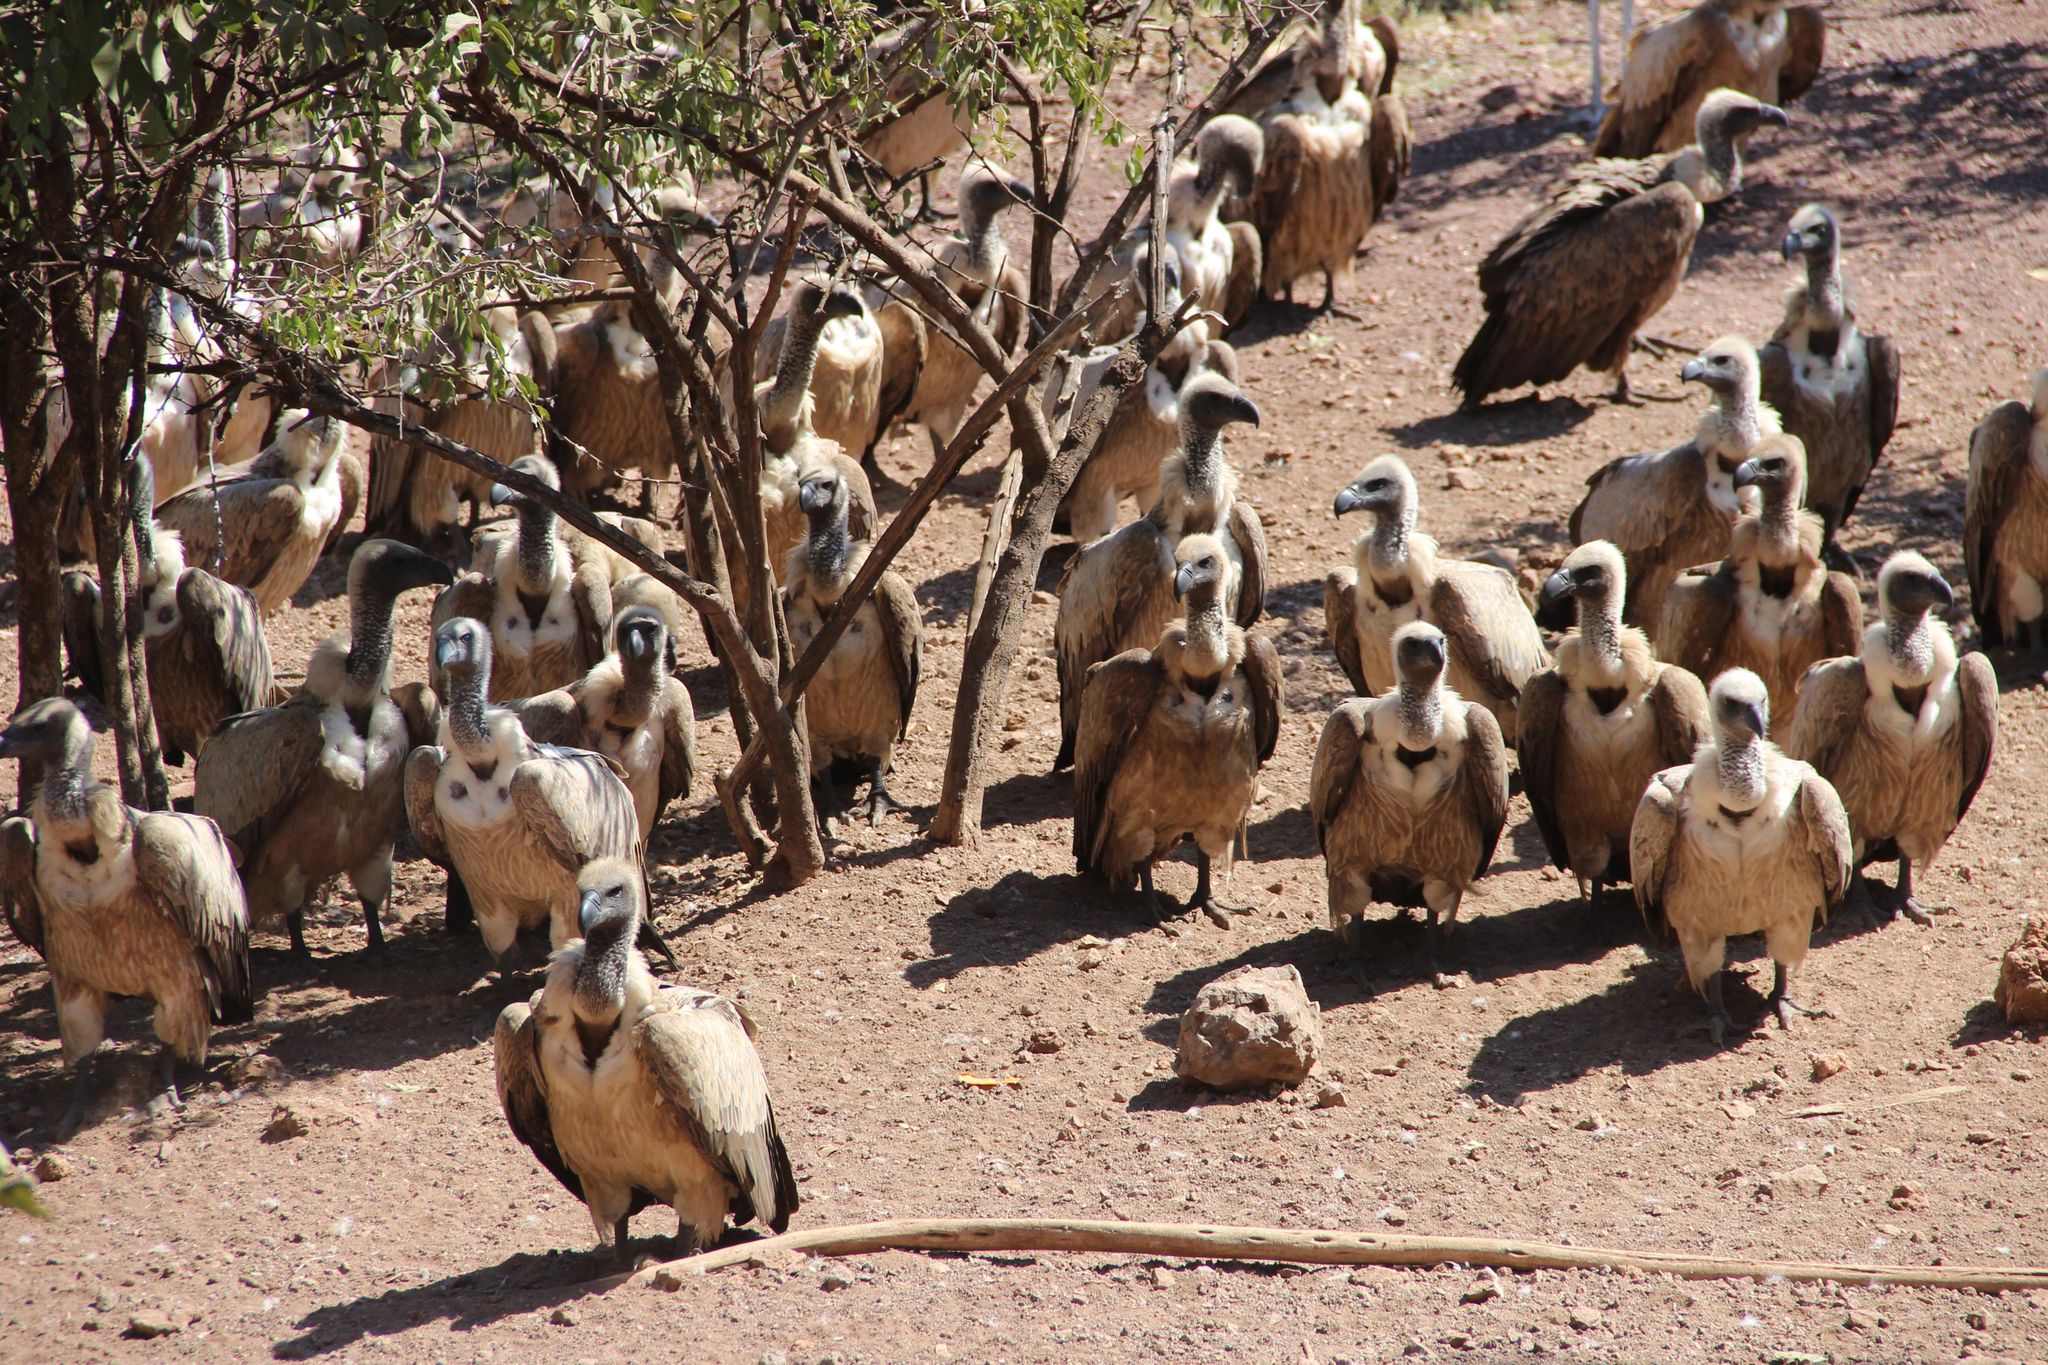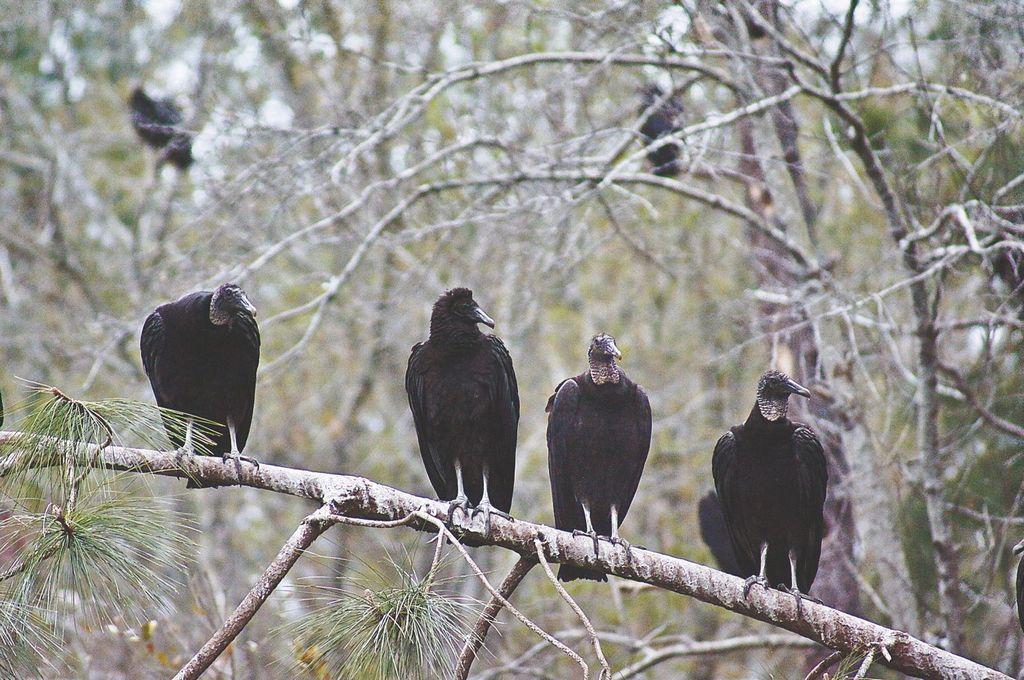The first image is the image on the left, the second image is the image on the right. For the images displayed, is the sentence "All vultures in one image are off the ground." factually correct? Answer yes or no. Yes. The first image is the image on the left, the second image is the image on the right. Considering the images on both sides, is "In 1 of the images, at least 1 bird is flying." valid? Answer yes or no. No. 